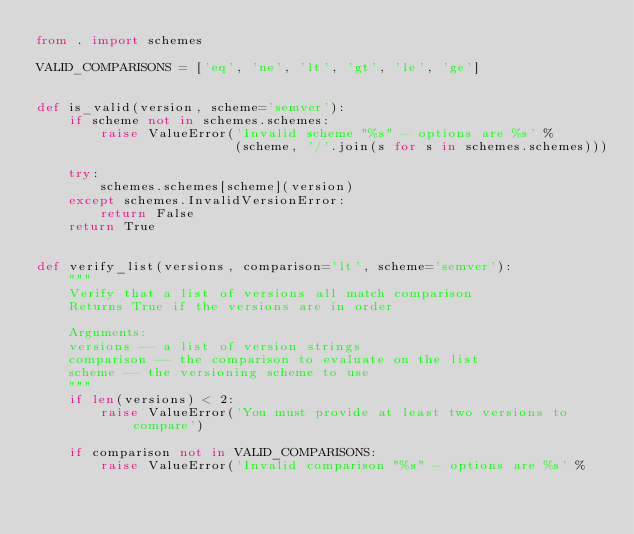Convert code to text. <code><loc_0><loc_0><loc_500><loc_500><_Python_>from . import schemes

VALID_COMPARISONS = ['eq', 'ne', 'lt', 'gt', 'le', 'ge']


def is_valid(version, scheme='semver'):
    if scheme not in schemes.schemes:
        raise ValueError('Invalid scheme "%s" - options are %s' %
                         (scheme, '/'.join(s for s in schemes.schemes)))

    try:
        schemes.schemes[scheme](version)
    except schemes.InvalidVersionError:
        return False
    return True


def verify_list(versions, comparison='lt', scheme='semver'):
    """
    Verify that a list of versions all match comparison
    Returns True if the versions are in order

    Arguments:
    versions -- a list of version strings
    comparison -- the comparison to evaluate on the list
    scheme -- the versioning scheme to use
    """
    if len(versions) < 2:
        raise ValueError('You must provide at least two versions to compare')

    if comparison not in VALID_COMPARISONS:
        raise ValueError('Invalid comparison "%s" - options are %s' %</code> 